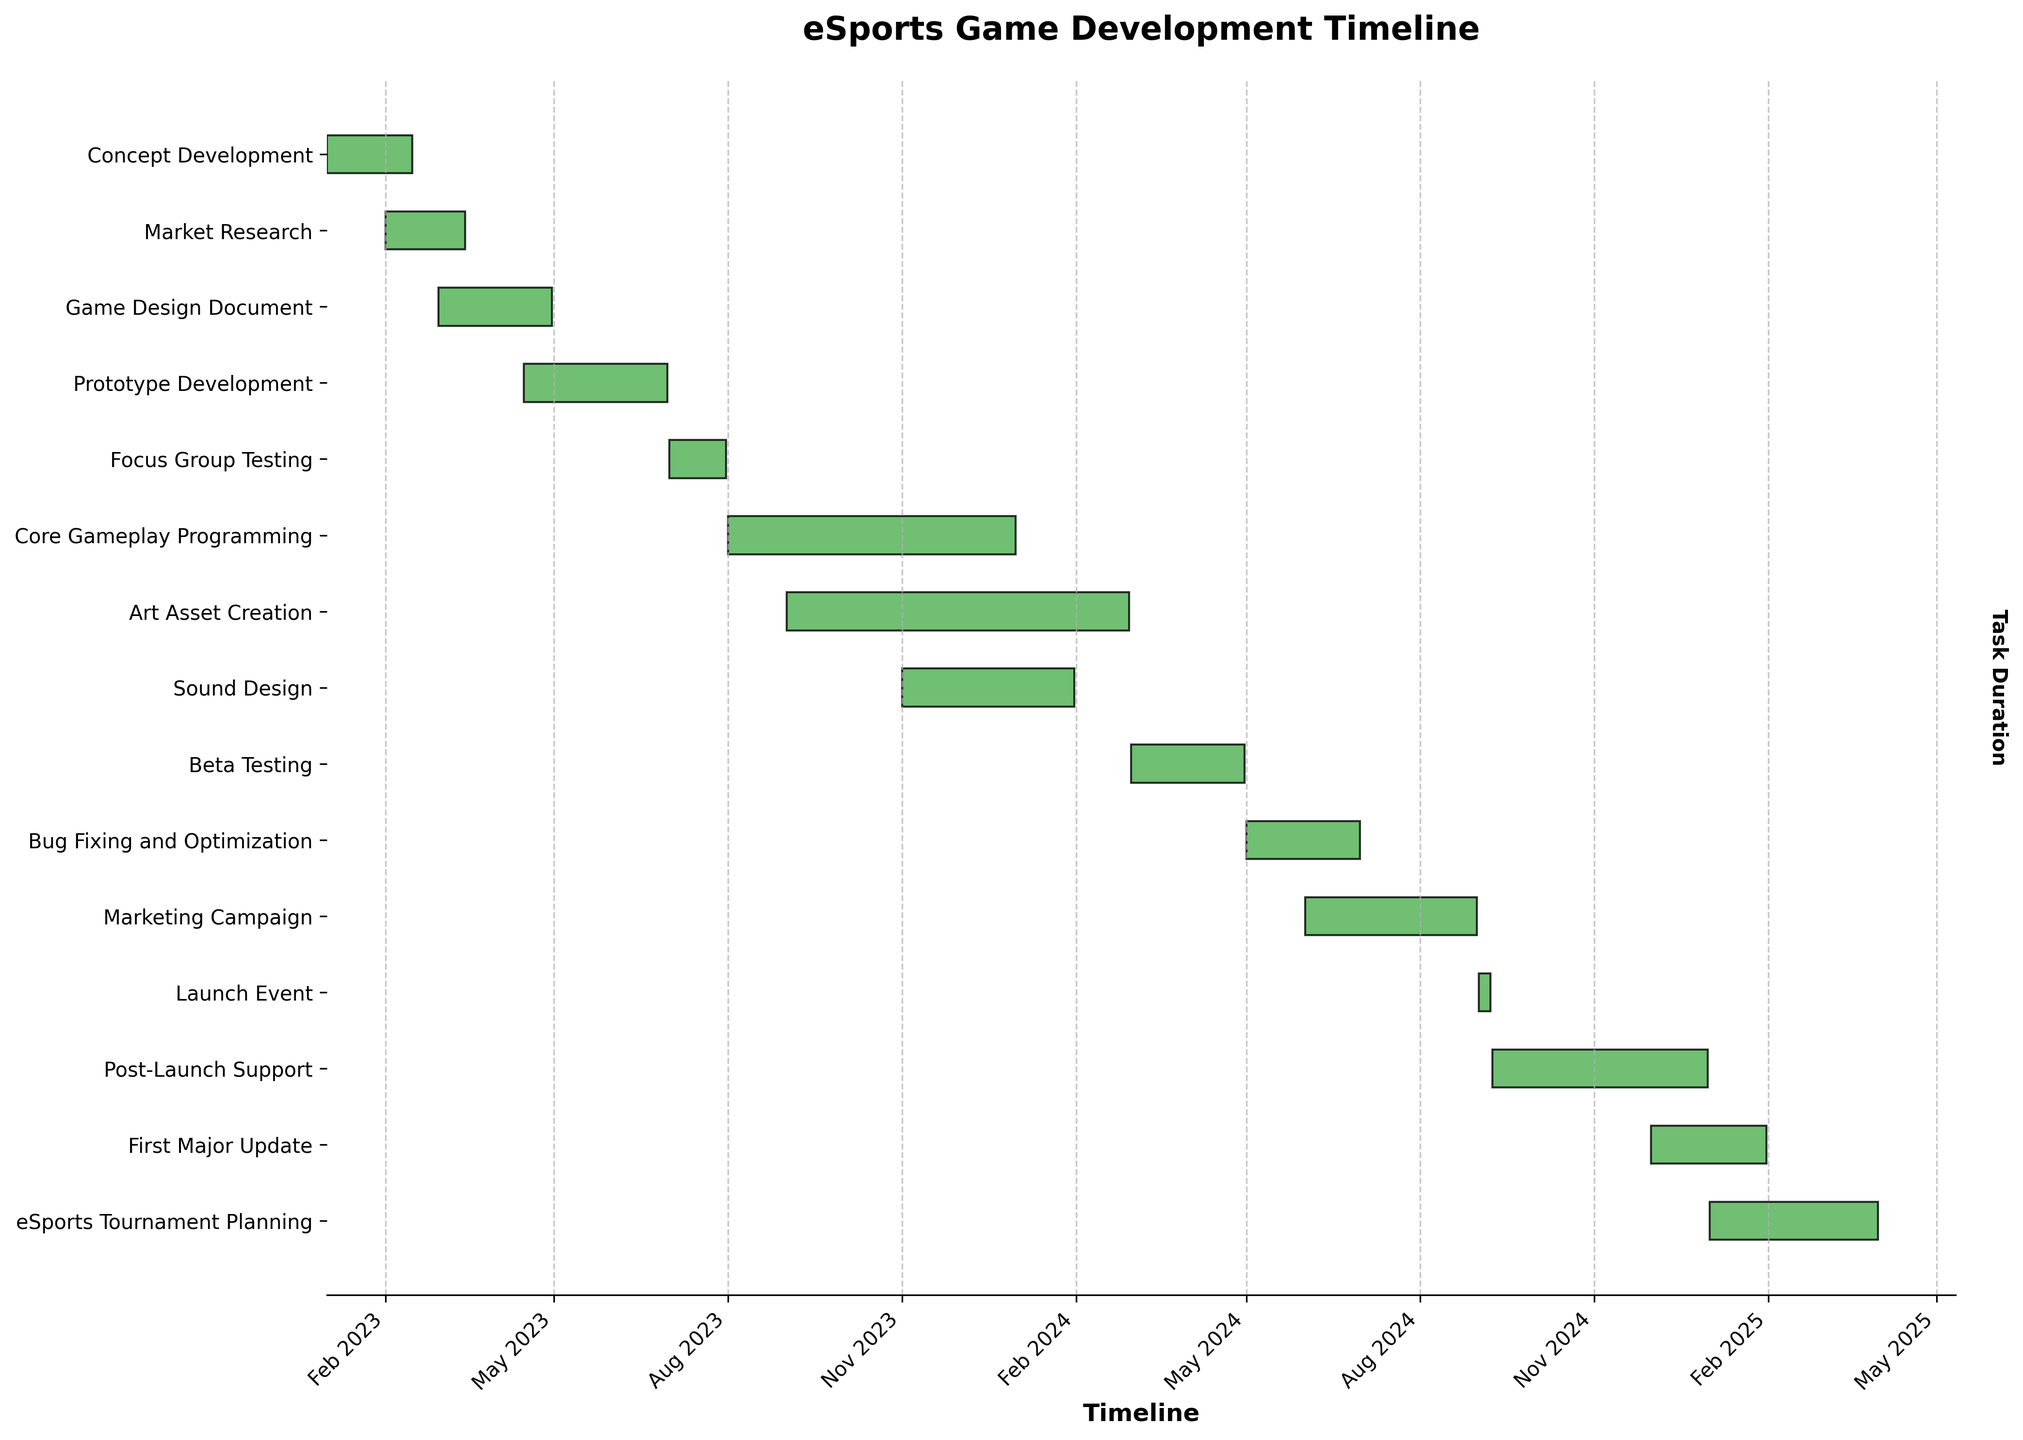What is the title of the chart? The chart title is usually displayed at the top of the figure. In this case, it's "eSports Game Development Timeline".
Answer: eSports Game Development Timeline What is the duration of the Concept Development phase? The Concept Development phase starts on 2023-01-01 and ends on 2023-02-15. To find the duration, calculate the difference between these two dates.
Answer: 45 days How many tasks overlap with the Market Research phase? To find the overlapping tasks, identify the timeframe of Market Research (2023-02-01 to 2023-03-15) and check which other tasks have dates that fall within this range. Both Concept Development and Game Design Document overlap with Market Research.
Answer: 2 tasks Which task has the longest duration? To determine this, calculate the duration of each task by subtracting the start date from the end date and compare the results. Core Gameplay Programming runs from 2023-08-01 to 2023-12-31, which is the longest duration.
Answer: Core Gameplay Programming What tasks are scheduled to start before July 2023? List the tasks that have start dates before 2023-07-01. These include Concept Development, Market Research, Game Design Document, and Prototype Development.
Answer: 4 tasks How many tasks start after the launch event? The Launch Event is from 2024-09-01 to 2024-09-07. Identify tasks with start dates after 2024-09-07, which are Post-Launch Support, First Major Update, and eSports Tournament Planning.
Answer: 3 tasks Which task is scheduled to be shortest? To find the shortest task, calculate the duration for each task and find the minimum. The Launch Event starts on 2024-09-01 and ends on 2024-09-07, lasting only 7 days.
Answer: Launch Event Are any tasks planned to overlap with the Beta Testing phase? Beta Testing is scheduled from 2024-03-01 to 2024-04-30. Identify tasks that fall within this date range. No other task overlaps with Beta Testing directly.
Answer: No Which phase directly precedes the Marketing Campaign? The Marketing Campaign starts on 2024-06-01. Determine which phase ends immediately before this date. Bug Fixing and Optimization ends on 2024-06-30, directly preceding it.
Answer: Bug Fixing and Optimization When does the Art Asset Creation phase begin and end? Look at the timeline for Art Asset Creation which starts on 2023-09-01 and ends on 2024-02-29.
Answer: 2023-09-01 to 2024-02-29 